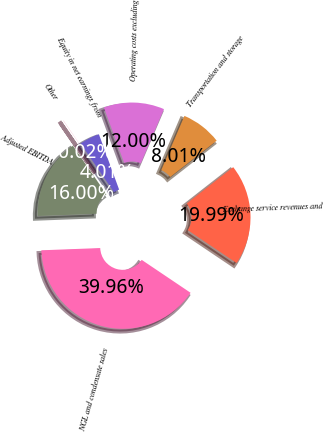Convert chart. <chart><loc_0><loc_0><loc_500><loc_500><pie_chart><fcel>NGL and condensate sales<fcel>Exchange service revenues and<fcel>Transportation and storage<fcel>Operating costs excluding<fcel>Equity in net earnings from<fcel>Other<fcel>Adjusted EBITDA<nl><fcel>39.96%<fcel>19.99%<fcel>8.01%<fcel>12.0%<fcel>4.01%<fcel>0.02%<fcel>16.0%<nl></chart> 